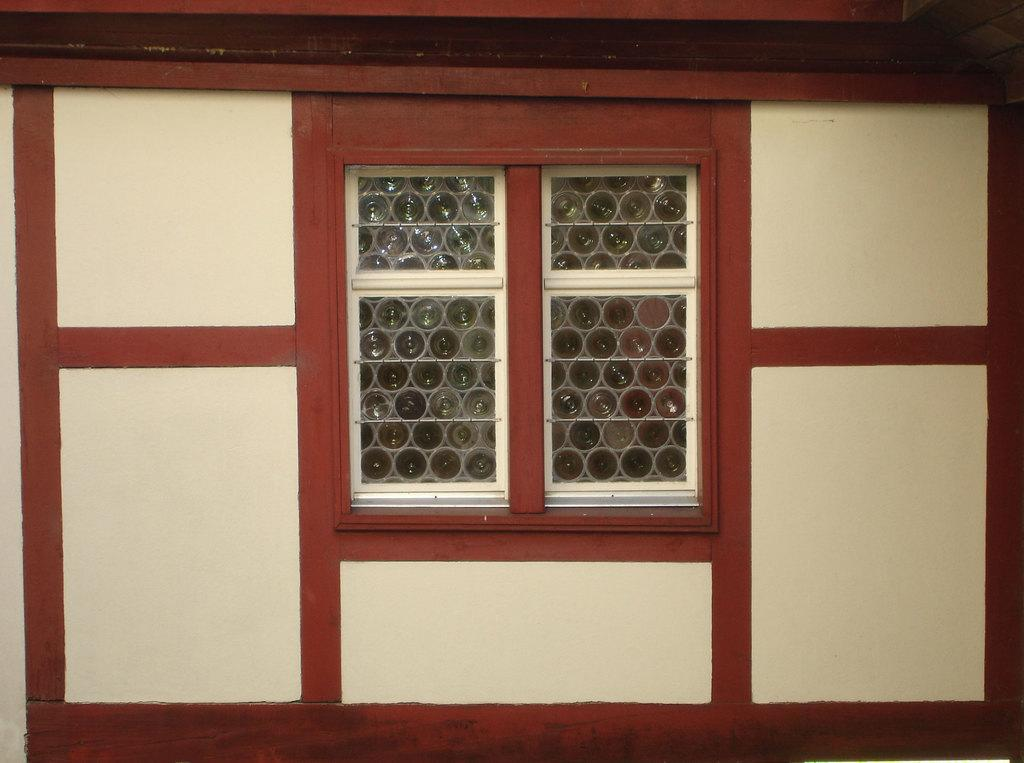What type of structure is visible in the image? There is a building in the image. Can you describe a specific feature of the building? There is a window in the center of the image. Where is the secretary sitting near the lake in the image? There is no secretary or lake present in the image; it only features a building with a window. 